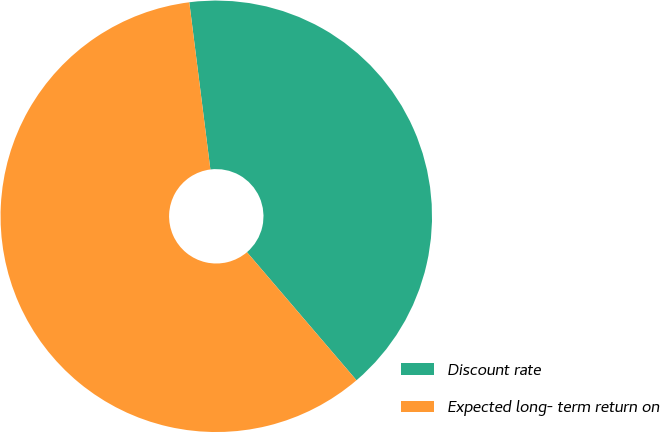Convert chart. <chart><loc_0><loc_0><loc_500><loc_500><pie_chart><fcel>Discount rate<fcel>Expected long- term return on<nl><fcel>40.74%<fcel>59.26%<nl></chart> 